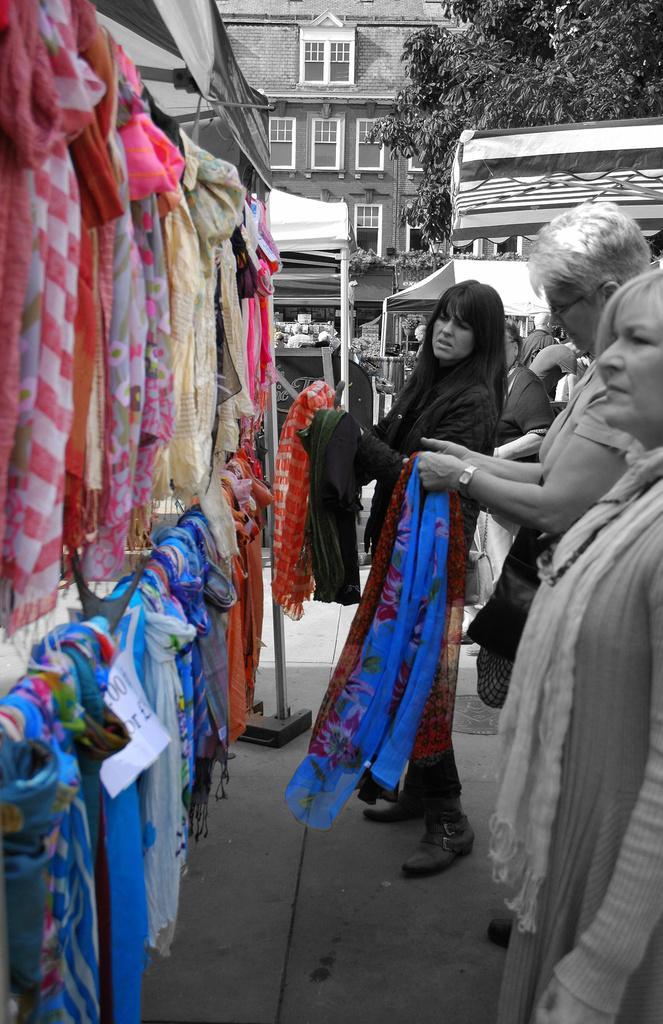Could you give a brief overview of what you see in this image? In this image I can see a crowd on the road and clothes are hanged in a shop. In the background I can see buildings, trees and poles. This image is taken during a day on the street. 